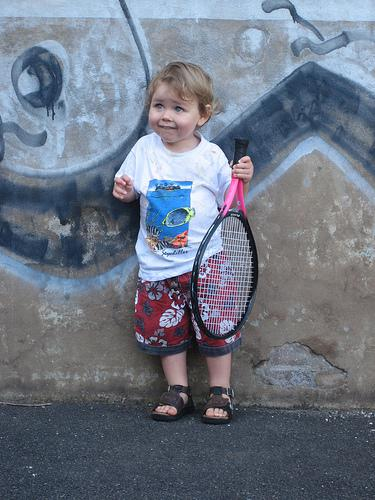Question: who is standing next to the boy?
Choices:
A. A woman.
B. No one.
C. A young child.
D. A man.
Answer with the letter. Answer: B Question: how many people are in the photo?
Choices:
A. Two.
B. Three.
C. Four.
D. One.
Answer with the letter. Answer: D Question: what color is the tennis racket?
Choices:
A. Pink.
B. Black.
C. Green.
D. Red.
Answer with the letter. Answer: A Question: what color hair does the little boy have?
Choices:
A. Brown.
B. Black.
C. Red.
D. Blonde.
Answer with the letter. Answer: D Question: what pattern is the boy's shorts?
Choices:
A. Hawaiian flowers.
B. Plaid.
C. Blue and green stripes.
D. Yellow stars.
Answer with the letter. Answer: A Question: what is the boy holding in his left hand?
Choices:
A. Baseball bat.
B. Tennis racket.
C. Water bottle.
D. Golf club.
Answer with the letter. Answer: B 